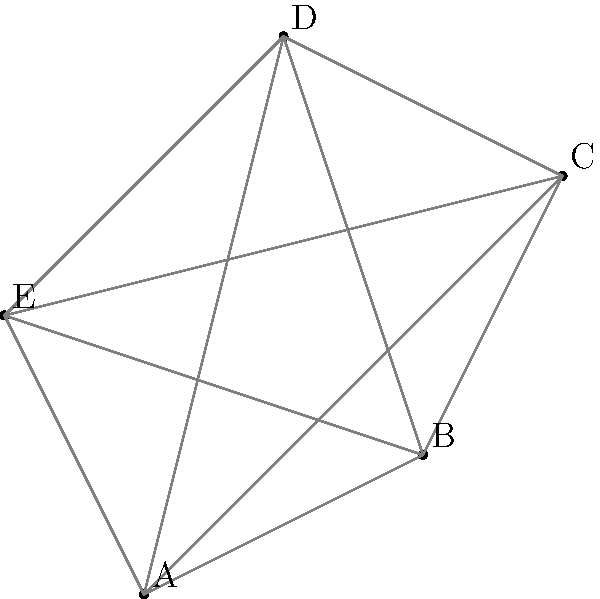In a darts tournament in Berlin, a player needs to collect darts from five positions on the floor, represented by points A, B, C, D, and E. The distances between each pair of points are given in meters. What is the minimum total distance the player must travel to collect all darts, starting and ending at point A? To solve this problem, we need to find the shortest path that visits all points and returns to the starting point. This is known as the Traveling Salesman Problem (TSP). For a small number of points like in this case, we can use the following steps:

1. Calculate the distances between all pairs of points:
   AB = 2.24m, AC = 3.61m, AD = 4.12m, AE = 2.24m
   BC = 2.24m, BD = 3.16m, BE = 3.61m
   CD = 2.24m, CE = 4.47m
   DE = 2.83m

2. List all possible routes starting and ending at A:
   ABCDEA, ABCEDA, ABDCEA, ABDECA, ABEDCA, ABECDA
   ACBDEA, ACBEDA, ACDEBA, ACDEБА,ACEBDA, ACEDBA
   ADBCEA, ADBECA, ADCBEA, ADCEBA, ADEBCA, ADECBA
   AEBCDA, AEBDCA, AECBDA, AECDBA, AEDBCA, AEDCBA

3. Calculate the total distance for each route and find the minimum:

   The shortest route is ACDEBA with a total distance of:
   AC + CD + DE + EB + BA = 3.61 + 2.24 + 2.83 + 3.61 + 2.24 = 14.53m

Therefore, the minimum total distance the player must travel is 14.53 meters.
Answer: 14.53 meters 